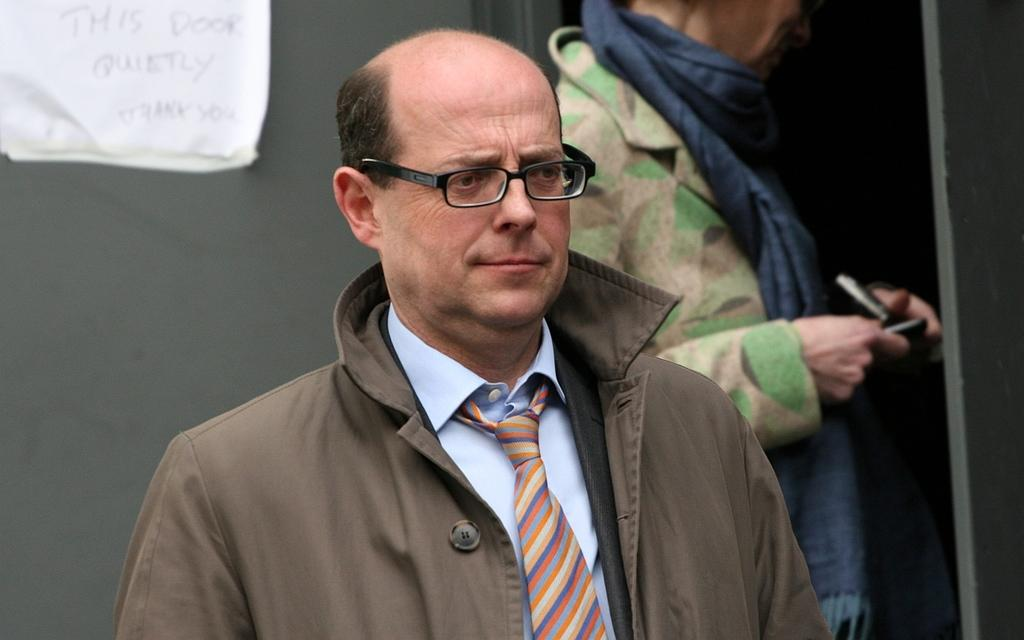How many people are in the image? There are people in the image, but the exact number is not specified. What is present on the wall in the image? There is a wall in the image, and a poster is present on it. What else can be seen in the image besides people and the wall? There are objects in the image. Can you describe the appearance of one of the people in the image? One person is wearing a jacket and spectacles. What is another person doing in the image? Another person is holding objects. What type of lumber is being used to build the appliance in the image? There is no lumber or appliance present in the image. How many yards of fabric were used to create the yard in the image? There is no yard or fabric present in the image. 